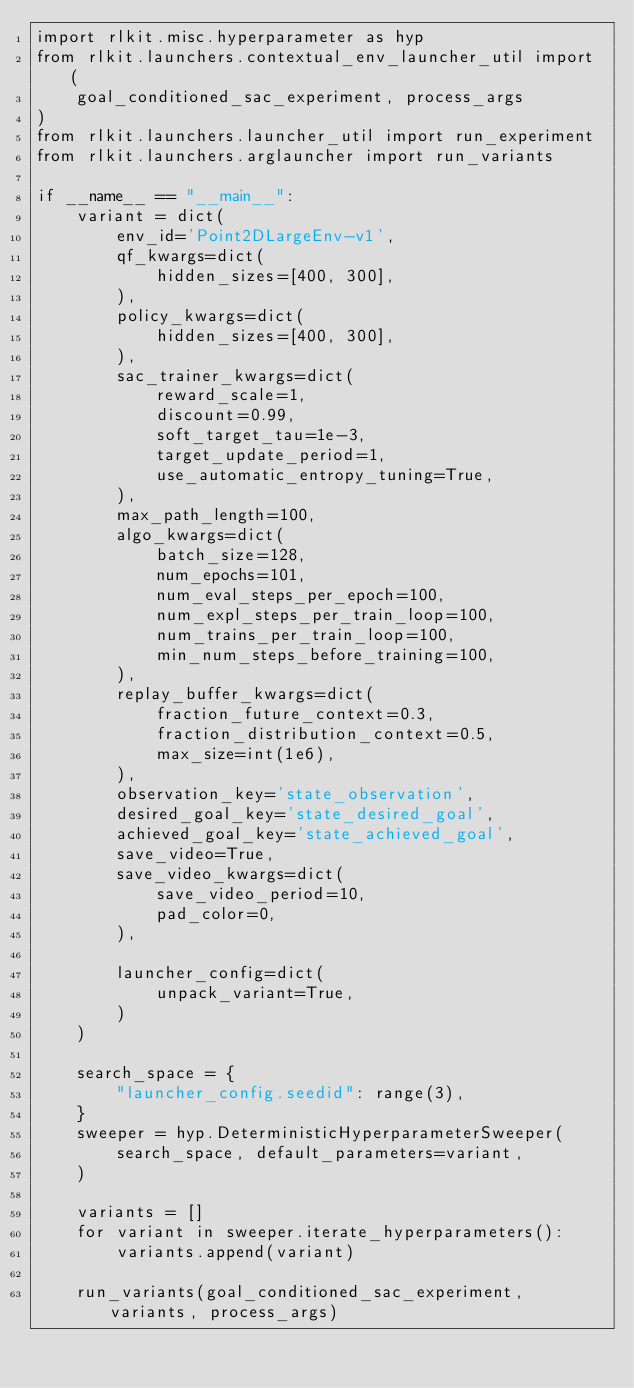<code> <loc_0><loc_0><loc_500><loc_500><_Python_>import rlkit.misc.hyperparameter as hyp
from rlkit.launchers.contextual_env_launcher_util import (
    goal_conditioned_sac_experiment, process_args
)
from rlkit.launchers.launcher_util import run_experiment
from rlkit.launchers.arglauncher import run_variants

if __name__ == "__main__":
    variant = dict(
        env_id='Point2DLargeEnv-v1',
        qf_kwargs=dict(
            hidden_sizes=[400, 300],
        ),
        policy_kwargs=dict(
            hidden_sizes=[400, 300],
        ),
        sac_trainer_kwargs=dict(
            reward_scale=1,
            discount=0.99,
            soft_target_tau=1e-3,
            target_update_period=1,
            use_automatic_entropy_tuning=True,
        ),
        max_path_length=100,
        algo_kwargs=dict(
            batch_size=128,
            num_epochs=101,
            num_eval_steps_per_epoch=100,
            num_expl_steps_per_train_loop=100,
            num_trains_per_train_loop=100,
            min_num_steps_before_training=100,
        ),
        replay_buffer_kwargs=dict(
            fraction_future_context=0.3,
            fraction_distribution_context=0.5,
            max_size=int(1e6),
        ),
        observation_key='state_observation',
        desired_goal_key='state_desired_goal',
        achieved_goal_key='state_achieved_goal',
        save_video=True,
        save_video_kwargs=dict(
            save_video_period=10,
            pad_color=0,
        ),

        launcher_config=dict(
            unpack_variant=True,
        )
    )

    search_space = {
        "launcher_config.seedid": range(3),
    }
    sweeper = hyp.DeterministicHyperparameterSweeper(
        search_space, default_parameters=variant,
    )

    variants = []
    for variant in sweeper.iterate_hyperparameters():
        variants.append(variant)

    run_variants(goal_conditioned_sac_experiment, variants, process_args)
</code> 